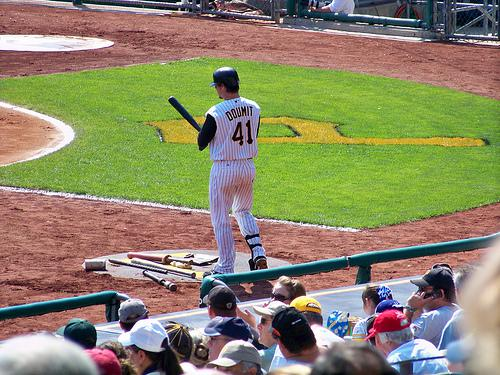Question: what does the batter have on his head?
Choices:
A. Safety helmet.
B. A sweatband.
C. A baseball cap.
D. A hood.
Answer with the letter. Answer: A Question: what is the batter holding?
Choices:
A. A glove.
B. The ball.
C. Baseball bat.
D. A helmet.
Answer with the letter. Answer: C Question: who has a number on the back of his shirt?
Choices:
A. The batter.
B. The umpire.
C. The mascot.
D. The boy in the stands.
Answer with the letter. Answer: A Question: how many red hats are in the crowd?
Choices:
A. One.
B. Three.
C. Two.
D. Four.
Answer with the letter. Answer: C Question: what color is the letter "P" painted?
Choices:
A. Yellow.
B. Red.
C. White.
D. BLue.
Answer with the letter. Answer: A Question: what number is on the batter's back?
Choices:
A. 09.
B. 23.
C. 41.
D. 13.
Answer with the letter. Answer: C 